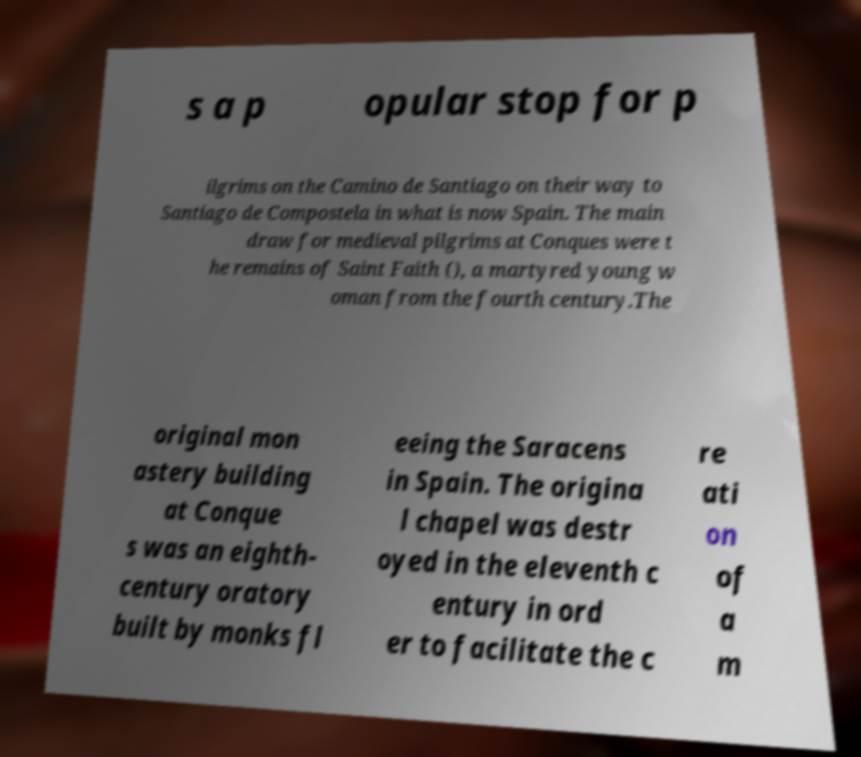I need the written content from this picture converted into text. Can you do that? s a p opular stop for p ilgrims on the Camino de Santiago on their way to Santiago de Compostela in what is now Spain. The main draw for medieval pilgrims at Conques were t he remains of Saint Faith (), a martyred young w oman from the fourth century.The original mon astery building at Conque s was an eighth- century oratory built by monks fl eeing the Saracens in Spain. The origina l chapel was destr oyed in the eleventh c entury in ord er to facilitate the c re ati on of a m 